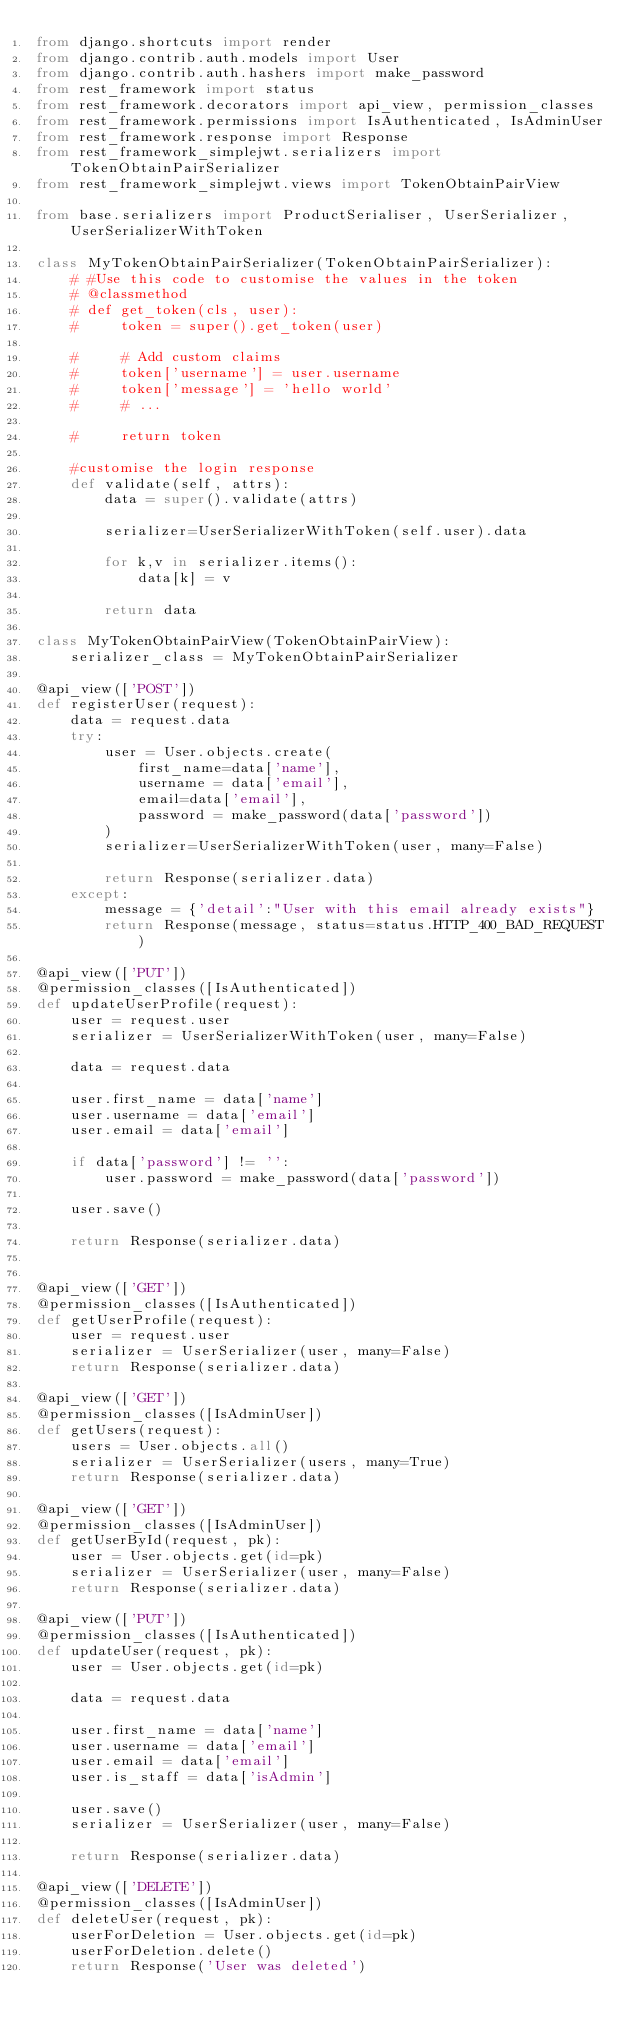Convert code to text. <code><loc_0><loc_0><loc_500><loc_500><_Python_>from django.shortcuts import render
from django.contrib.auth.models import User
from django.contrib.auth.hashers import make_password
from rest_framework import status
from rest_framework.decorators import api_view, permission_classes
from rest_framework.permissions import IsAuthenticated, IsAdminUser
from rest_framework.response import Response
from rest_framework_simplejwt.serializers import TokenObtainPairSerializer
from rest_framework_simplejwt.views import TokenObtainPairView

from base.serializers import ProductSerialiser, UserSerializer, UserSerializerWithToken

class MyTokenObtainPairSerializer(TokenObtainPairSerializer):
    # #Use this code to customise the values in the token
    # @classmethod
    # def get_token(cls, user):
    #     token = super().get_token(user)

    #     # Add custom claims
    #     token['username'] = user.username
    #     token['message'] = 'hello world'
    #     # ...

    #     return token

    #customise the login response
    def validate(self, attrs):
        data = super().validate(attrs)

        serializer=UserSerializerWithToken(self.user).data

        for k,v in serializer.items():
            data[k] = v

        return data

class MyTokenObtainPairView(TokenObtainPairView):
    serializer_class = MyTokenObtainPairSerializer

@api_view(['POST'])
def registerUser(request):
    data = request.data
    try:
        user = User.objects.create(
            first_name=data['name'],
            username = data['email'],
            email=data['email'],
            password = make_password(data['password'])
        )
        serializer=UserSerializerWithToken(user, many=False)

        return Response(serializer.data)
    except:
        message = {'detail':"User with this email already exists"}
        return Response(message, status=status.HTTP_400_BAD_REQUEST)

@api_view(['PUT'])
@permission_classes([IsAuthenticated])
def updateUserProfile(request):
    user = request.user
    serializer = UserSerializerWithToken(user, many=False)

    data = request.data

    user.first_name = data['name']
    user.username = data['email']
    user.email = data['email']

    if data['password'] != '':
        user.password = make_password(data['password'])

    user.save()

    return Response(serializer.data)


@api_view(['GET'])
@permission_classes([IsAuthenticated])
def getUserProfile(request):
    user = request.user
    serializer = UserSerializer(user, many=False)
    return Response(serializer.data)

@api_view(['GET'])
@permission_classes([IsAdminUser])
def getUsers(request):
    users = User.objects.all()
    serializer = UserSerializer(users, many=True)
    return Response(serializer.data)

@api_view(['GET'])
@permission_classes([IsAdminUser])
def getUserById(request, pk):
    user = User.objects.get(id=pk)
    serializer = UserSerializer(user, many=False)
    return Response(serializer.data)

@api_view(['PUT'])
@permission_classes([IsAuthenticated])
def updateUser(request, pk):
    user = User.objects.get(id=pk)

    data = request.data

    user.first_name = data['name']
    user.username = data['email']
    user.email = data['email']
    user.is_staff = data['isAdmin']

    user.save()
    serializer = UserSerializer(user, many=False)

    return Response(serializer.data)

@api_view(['DELETE'])
@permission_classes([IsAdminUser])
def deleteUser(request, pk):
    userForDeletion = User.objects.get(id=pk)
    userForDeletion.delete()
    return Response('User was deleted')</code> 